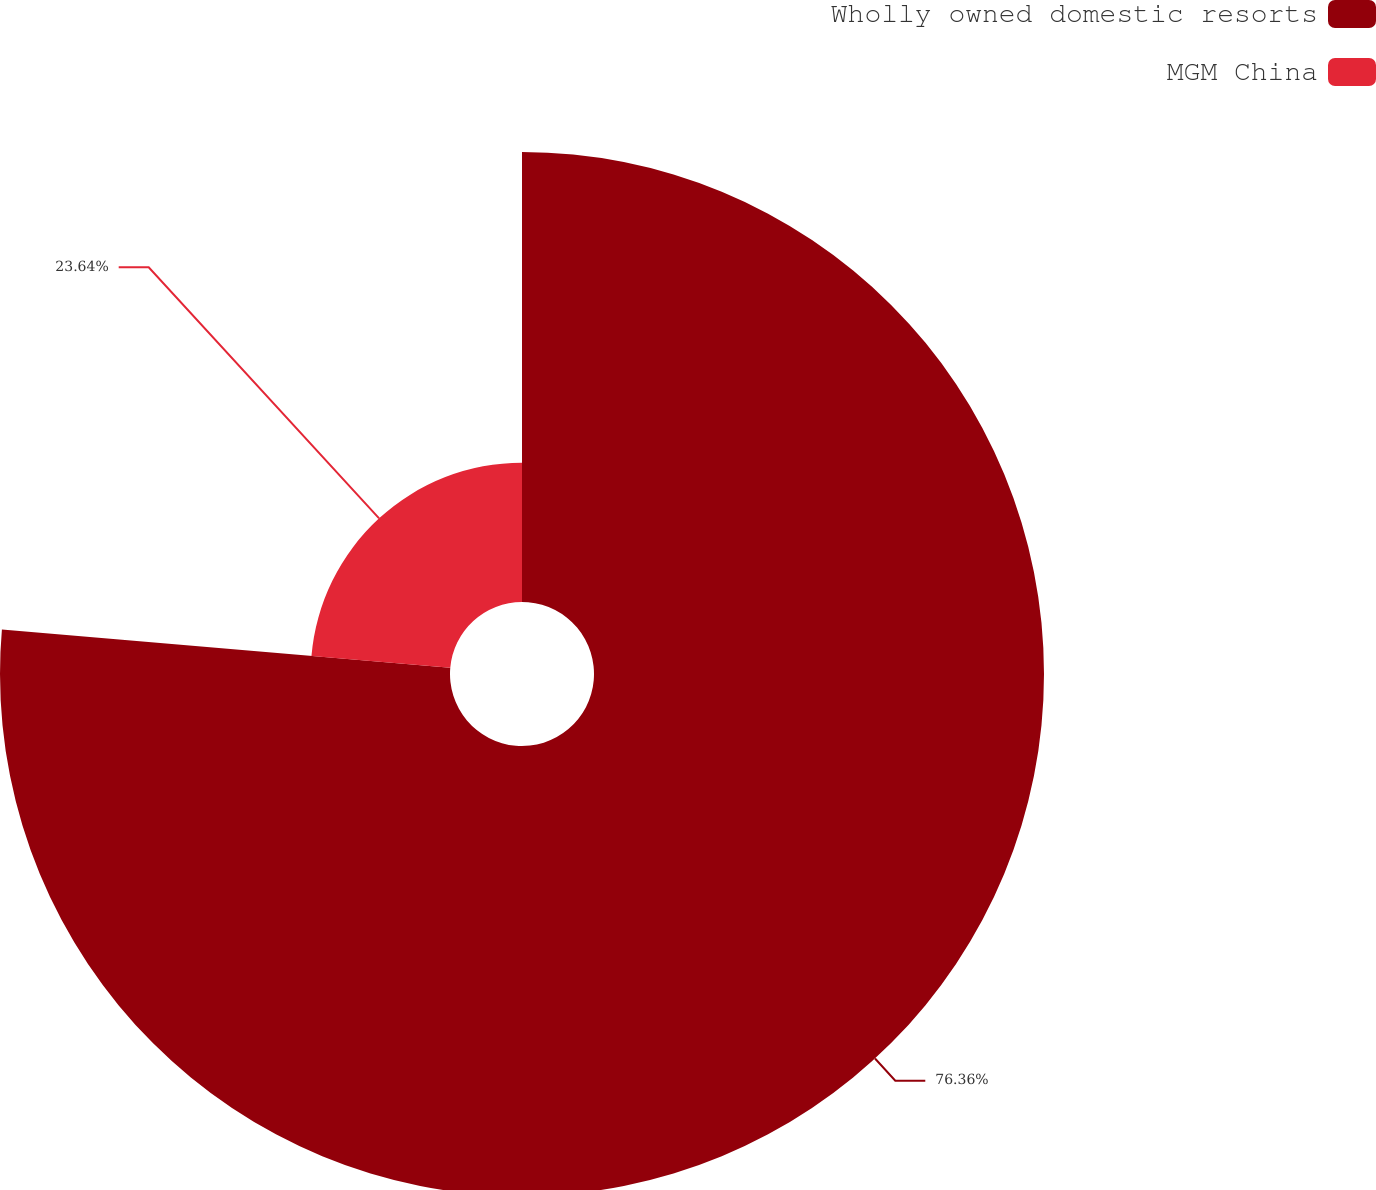Convert chart to OTSL. <chart><loc_0><loc_0><loc_500><loc_500><pie_chart><fcel>Wholly owned domestic resorts<fcel>MGM China<nl><fcel>76.36%<fcel>23.64%<nl></chart> 